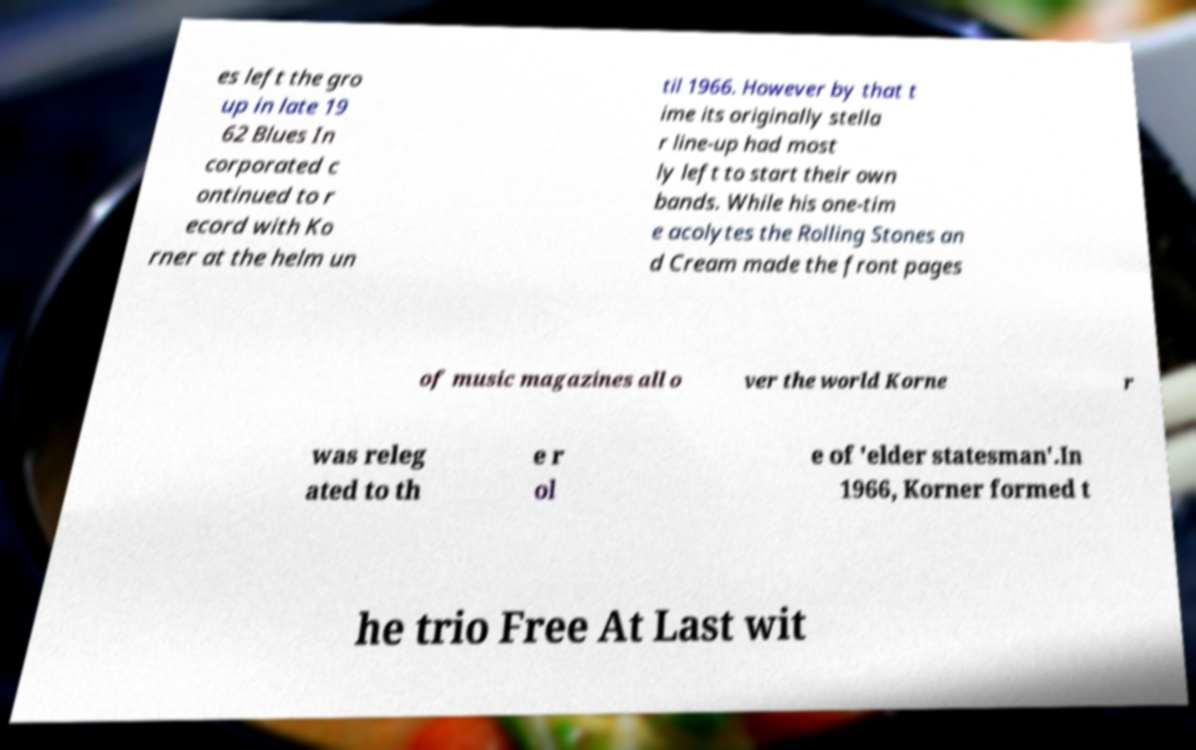I need the written content from this picture converted into text. Can you do that? es left the gro up in late 19 62 Blues In corporated c ontinued to r ecord with Ko rner at the helm un til 1966. However by that t ime its originally stella r line-up had most ly left to start their own bands. While his one-tim e acolytes the Rolling Stones an d Cream made the front pages of music magazines all o ver the world Korne r was releg ated to th e r ol e of 'elder statesman'.In 1966, Korner formed t he trio Free At Last wit 